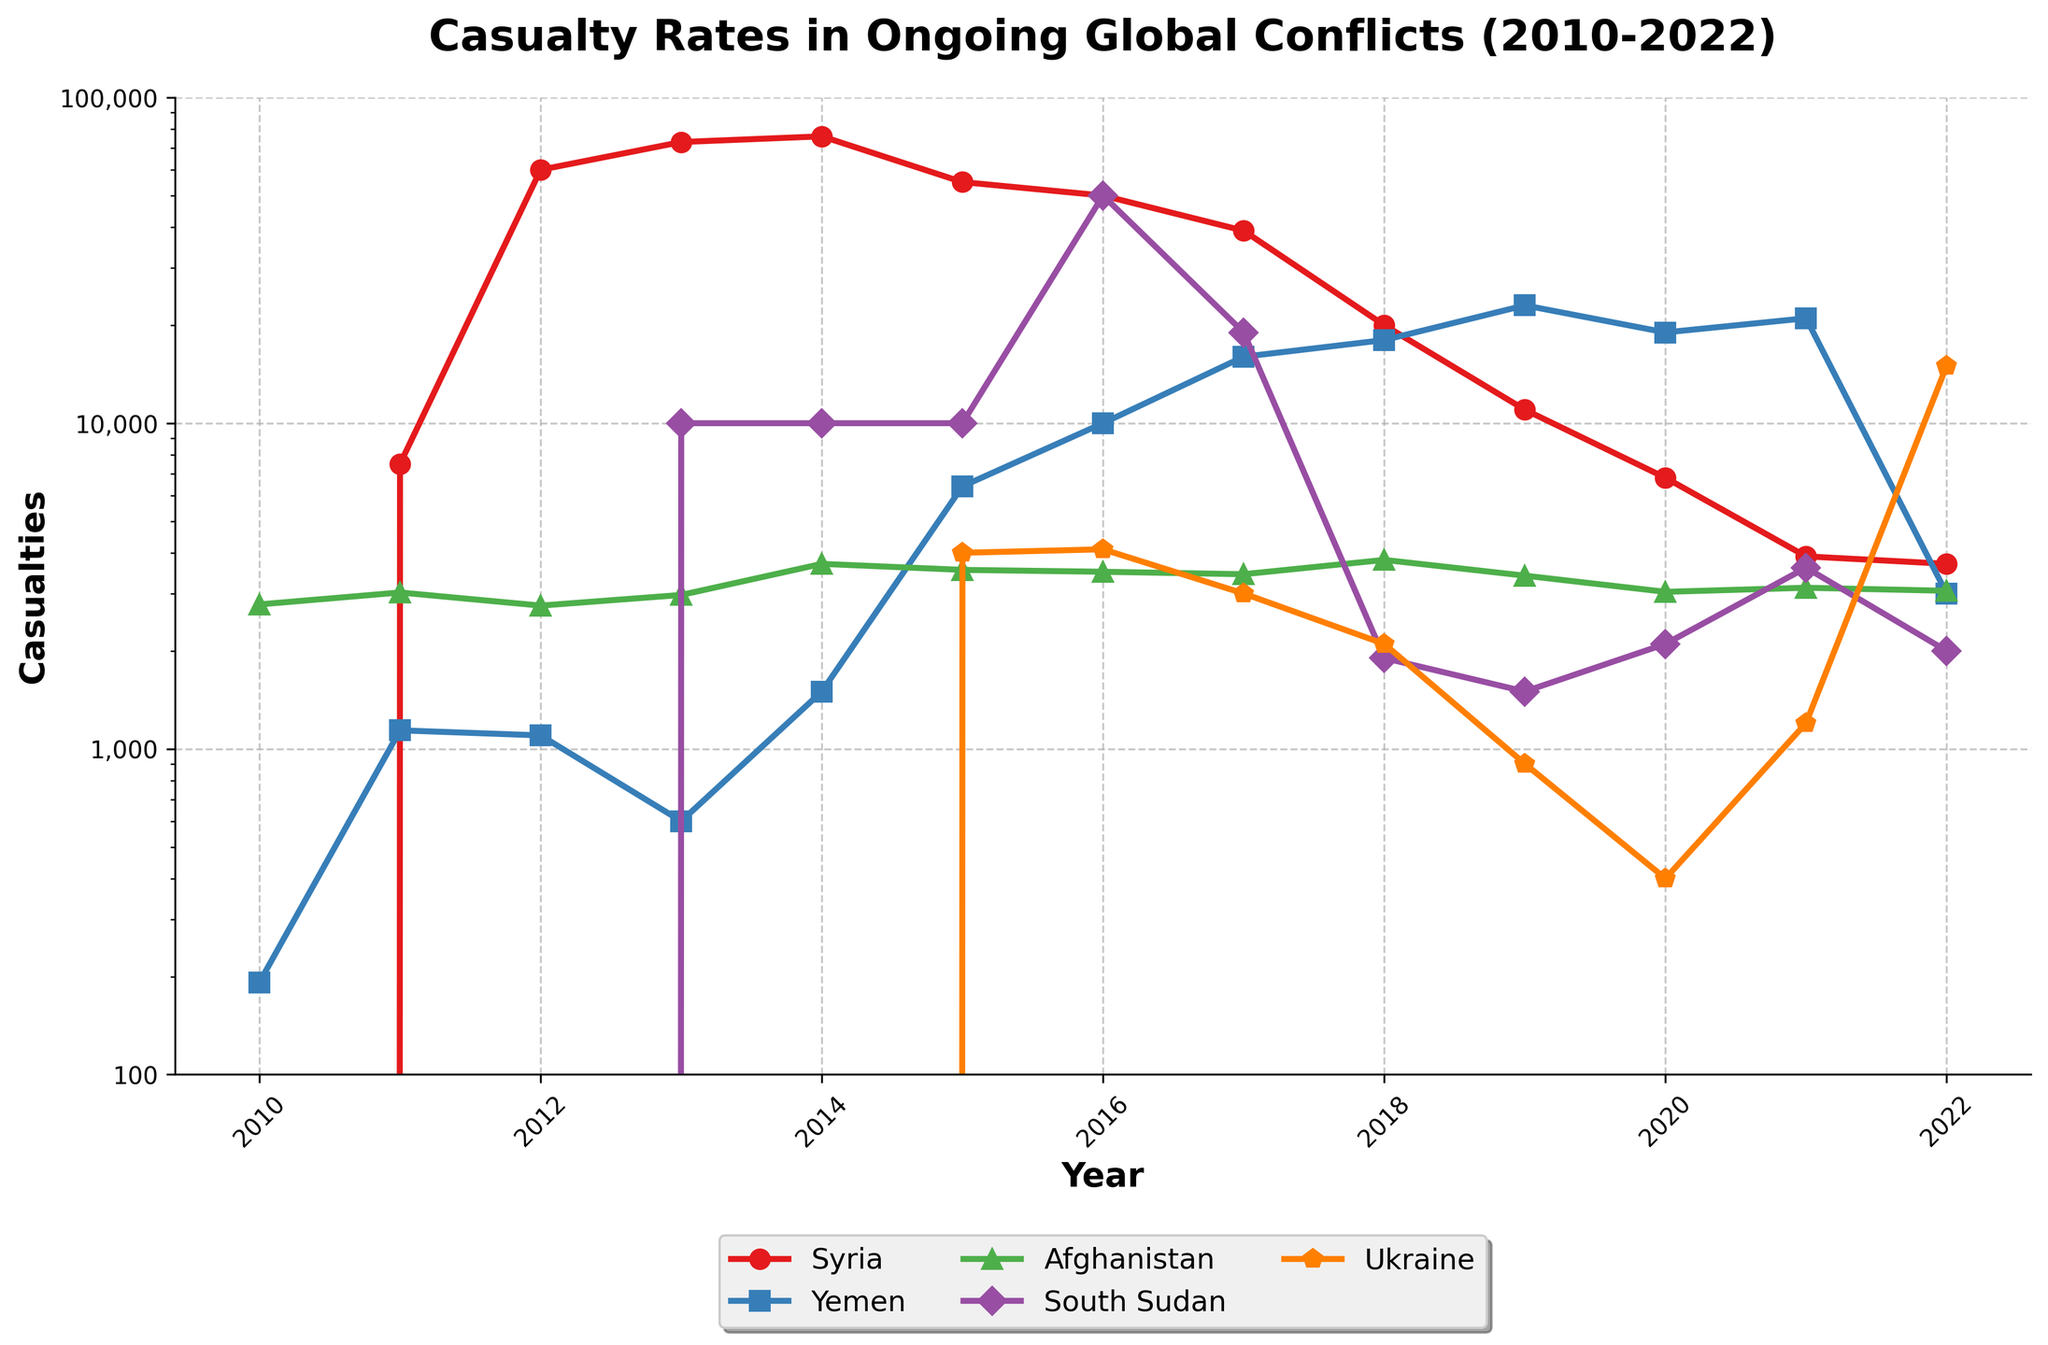What is the trend in casualty rates for Syria from 2010 to 2022? The figure shows a sharp rise in casualties in Syria from 2010, peaking in 2014, followed by a steady decline until 2022. This can be observed by examining the plotted line for Syria that reaches its highest point in 2014 and decreases thereafter.
Answer: Downward trend after 2014 Which year had the highest casualty rates in Yemen, and how many casualties were reported? By examining the line for Yemen, we can see the peak occurs in the year 2019. The y-axis value corresponding to this peak gives us the highest casualty count for that year.
Answer: 2019, 23,000 Between Afghanistan and South Sudan, which country had a higher casualty rate in 2016, and by how much? Based on the line plots for both countries in 2016, South Sudan’s casualty rate is significantly higher than Afghanistan’s. The figure indicates South Sudan had about 50,000 casualties, while Afghanistan had around 3,498. The difference is 50,000 - 3,498.
Answer: South Sudan, 46,502 What are the color and marker type used to represent Ukraine in the chart? The line and markers representing Ukraine are displayed in orange color with pentagon ('p') markers.
Answer: Orange, Pentagon marker How does the casualty count in Syria compare to Afghanistan's in 2012? According to the plot, Syria had around 60,000 casualties, whereas Afghanistan had approximately 2,754. This shows Syria had much higher casualties.
Answer: Syria > Afghanistan Compute the average casualties for Yemen from 2011 to 2019. From the data, the casualties for Yemen from 2011 to 2019 are: 1140, 1100, 600, 1500, 6400, 10000, 16000, 18000, 23000. Adding these and dividing by the number of years gives (1140 + 1100 + 600 + 1500 + 6400 + 10000 + 16000 + 18000 + 23000) / 9 = 10,526.
Answer: 10,526 In which year did South Sudan experience the lowest casualty rate, and how many casualties were reported? The plot for South Sudan shows the lowest point in 2019, where the casualty rate is around 1,500.
Answer: 2019, 1,500 Which conflict had the lowest casualty rate in 2020, and what was the count? Observing the lines for all countries in the year 2020, Ukraine’s line is at its lowest point with around 400 casualties.
Answer: Ukraine, 400 How did the casualty trends for Syria and Ukraine differ from 2018 to 2022? From 2018 to 2022, Syria shows a declining trend in casualties, whereas Ukraine experiences an initial dip followed by a significant rise in 2022. This can be seen from the respective lines representing these countries.
Answer: Syria declined, Ukraine increased in 2022 